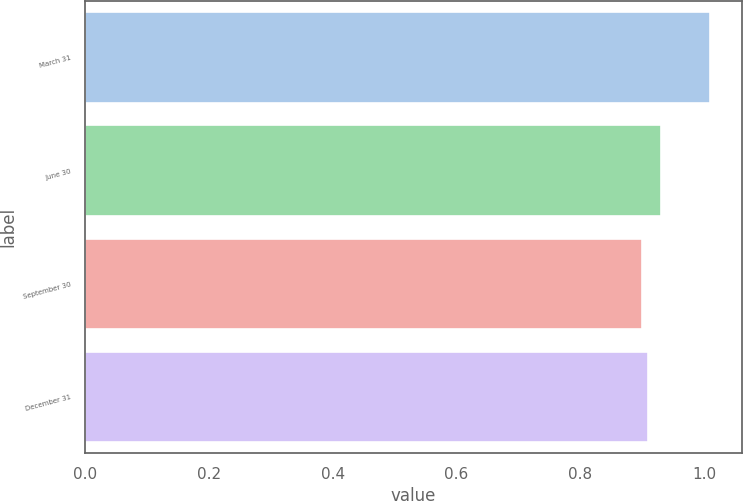Convert chart. <chart><loc_0><loc_0><loc_500><loc_500><bar_chart><fcel>March 31<fcel>June 30<fcel>September 30<fcel>December 31<nl><fcel>1.01<fcel>0.93<fcel>0.9<fcel>0.91<nl></chart> 